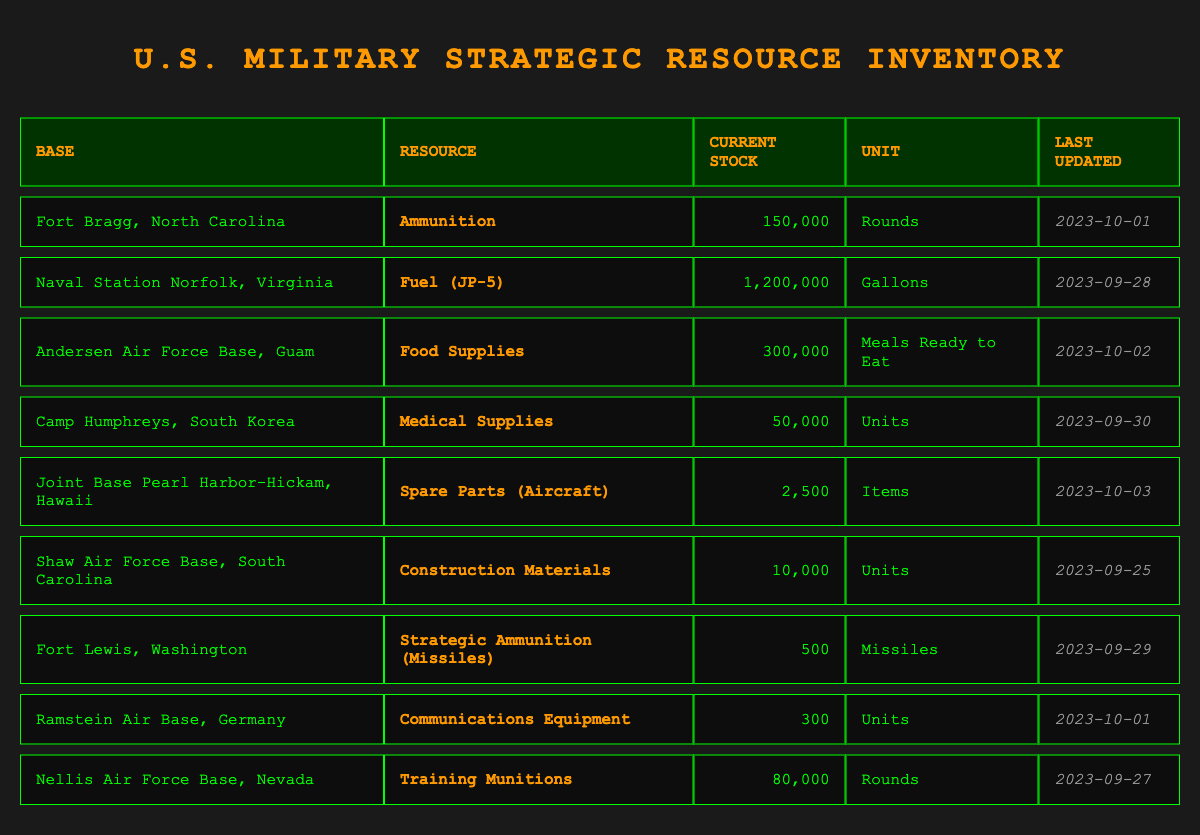What is the current stock of ammunition at Fort Bragg, North Carolina? The table lists the resource for Fort Bragg, North Carolina, which is ammunition, with a current stock of 150,000 rounds. Therefore, the answer is directly taken from the table.
Answer: 150,000 rounds Which base has the largest stock of fuel? From the table, Naval Station Norfolk, Virginia has a stock of 1,200,000 gallons of fuel (JP-5), which is the highest value listed among all bases for any resource. This requires identifying the relevant row and comparing it to others.
Answer: Naval Station Norfolk, Virginia How many more gallons of fuel does Naval Station Norfolk have compared to the medical supplies at Camp Humphreys? The current stock at Naval Station Norfolk is 1,200,000 gallons of fuel, while Camp Humphreys has 50,000 units of medical supplies. Since they are different units, we cannot directly compare them. The question is misleading as both are in different units. Thus, the answer centers on the fact that these cannot be compared.
Answer: Unable to compare directly due to different units Is there a base with less than 1,000 units of communications equipment? Reviewing the table shows that Ramstein Air Base has 300 units of communications equipment, which is indeed less than 1,000. Checking other bases shows that none have lower than this stock.
Answer: Yes What is the total current stock of food supplies in the inventory? The only base with food supplies listed is Andersen Air Force Base, with a stock of 300,000 Meals Ready to Eat. Since there is no other entry for food supplies, the total only consists of this amount. Thus, the answer is straightforward.
Answer: 300,000 Meals Ready to Eat 